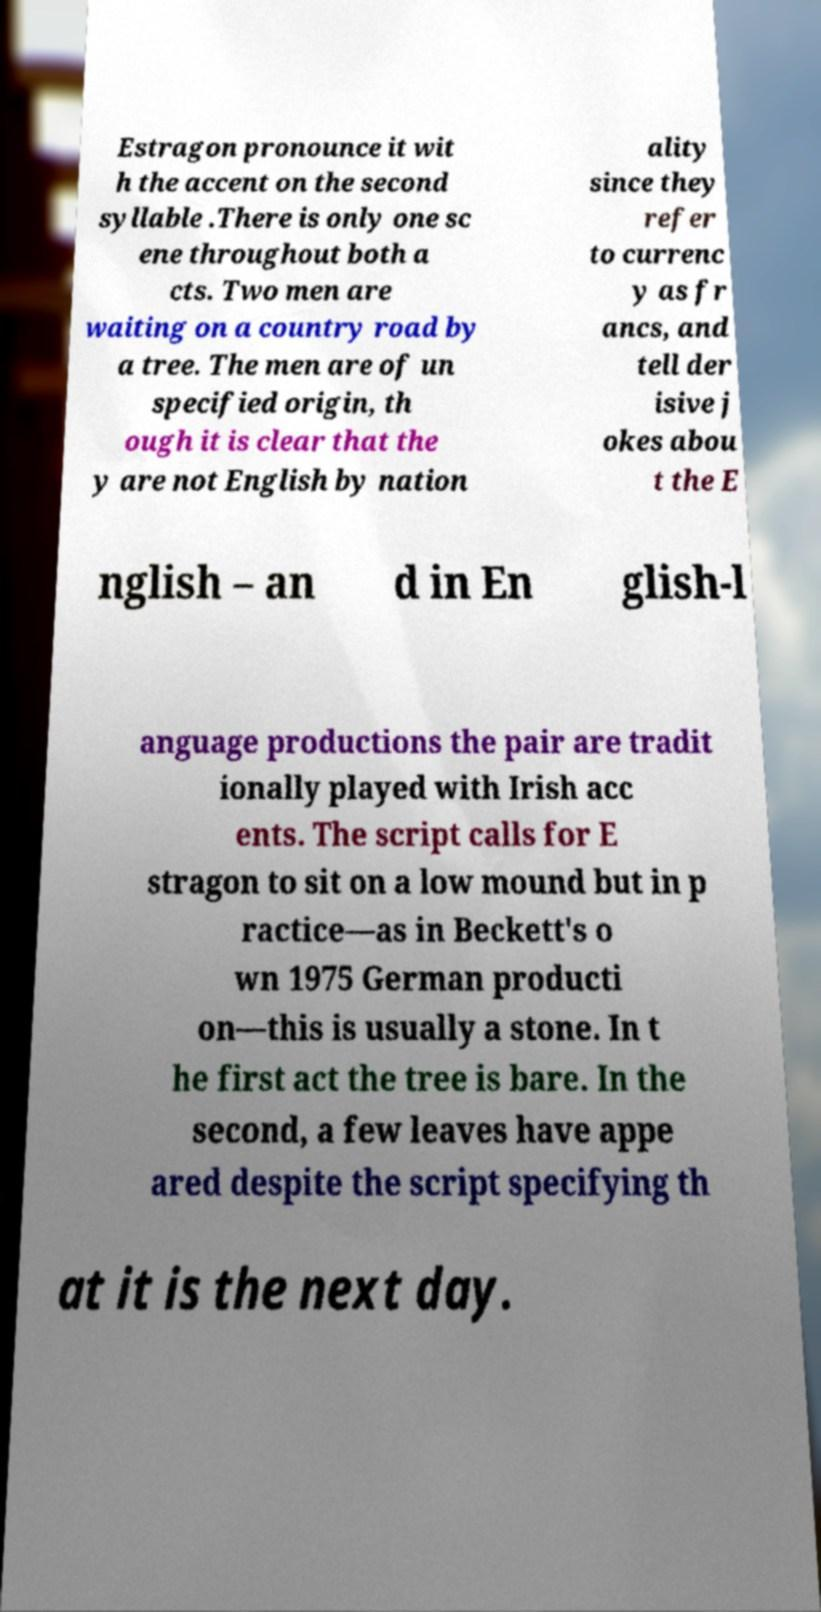What messages or text are displayed in this image? I need them in a readable, typed format. Estragon pronounce it wit h the accent on the second syllable .There is only one sc ene throughout both a cts. Two men are waiting on a country road by a tree. The men are of un specified origin, th ough it is clear that the y are not English by nation ality since they refer to currenc y as fr ancs, and tell der isive j okes abou t the E nglish – an d in En glish-l anguage productions the pair are tradit ionally played with Irish acc ents. The script calls for E stragon to sit on a low mound but in p ractice—as in Beckett's o wn 1975 German producti on—this is usually a stone. In t he first act the tree is bare. In the second, a few leaves have appe ared despite the script specifying th at it is the next day. 